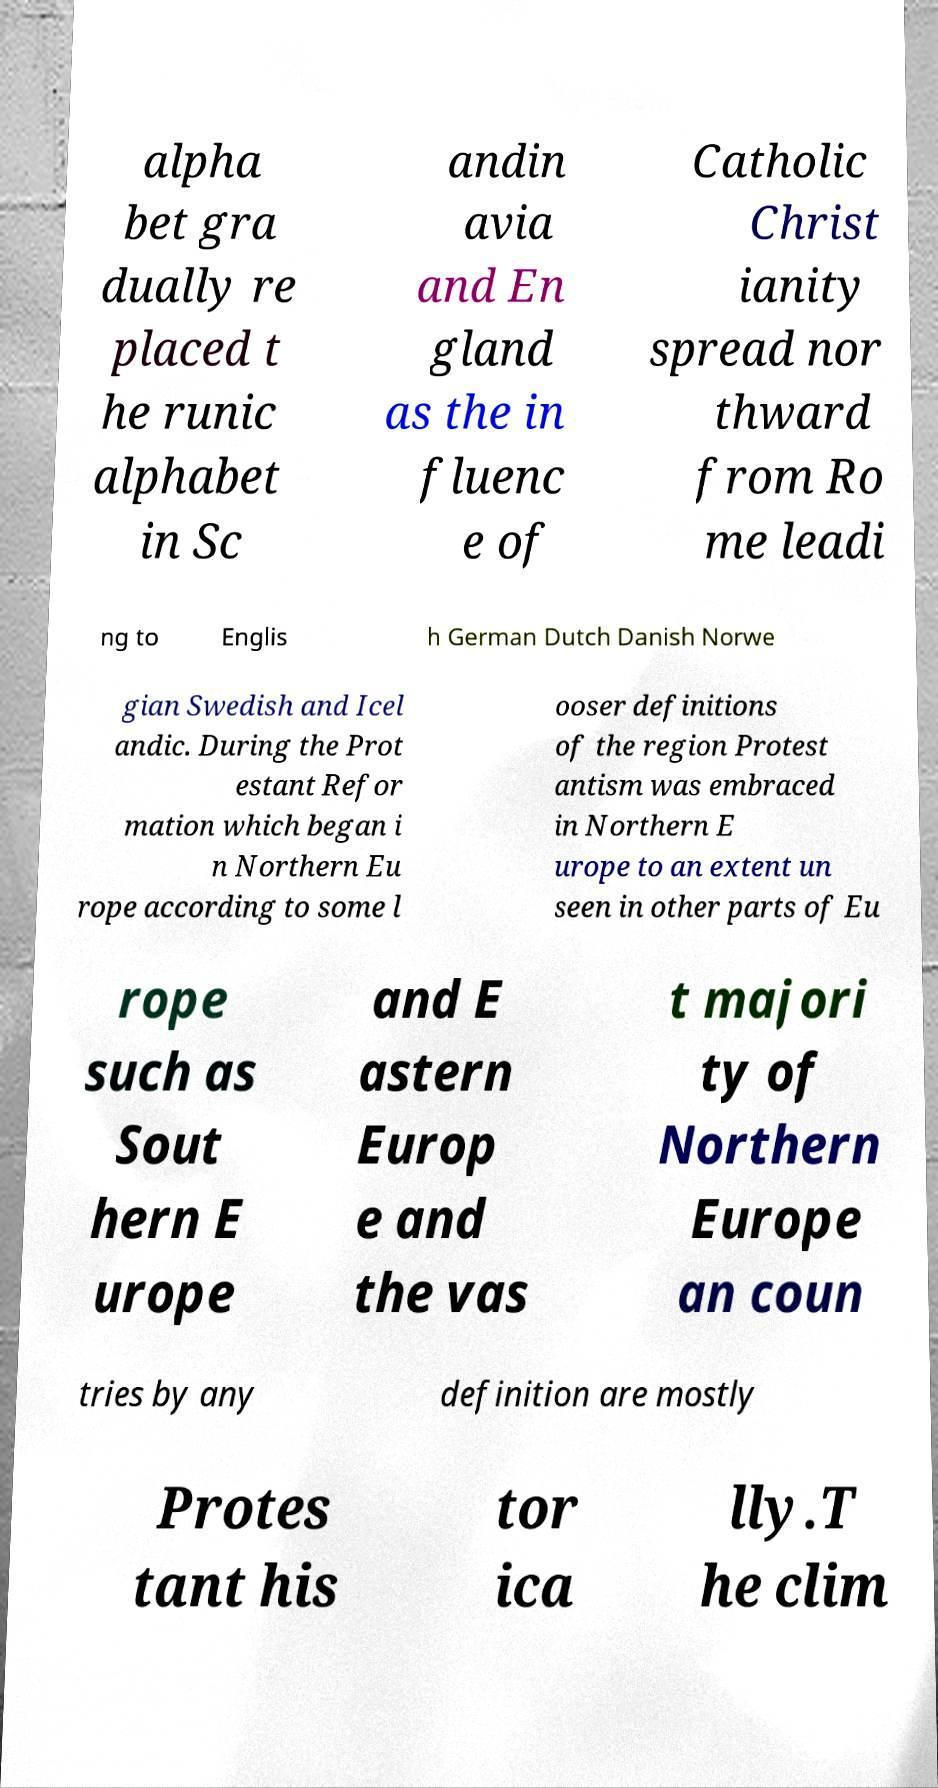There's text embedded in this image that I need extracted. Can you transcribe it verbatim? alpha bet gra dually re placed t he runic alphabet in Sc andin avia and En gland as the in fluenc e of Catholic Christ ianity spread nor thward from Ro me leadi ng to Englis h German Dutch Danish Norwe gian Swedish and Icel andic. During the Prot estant Refor mation which began i n Northern Eu rope according to some l ooser definitions of the region Protest antism was embraced in Northern E urope to an extent un seen in other parts of Eu rope such as Sout hern E urope and E astern Europ e and the vas t majori ty of Northern Europe an coun tries by any definition are mostly Protes tant his tor ica lly.T he clim 